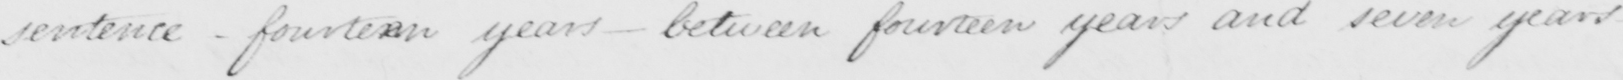What text is written in this handwritten line? sentence _ fourteen years _ between fourteen years and seven years _ 